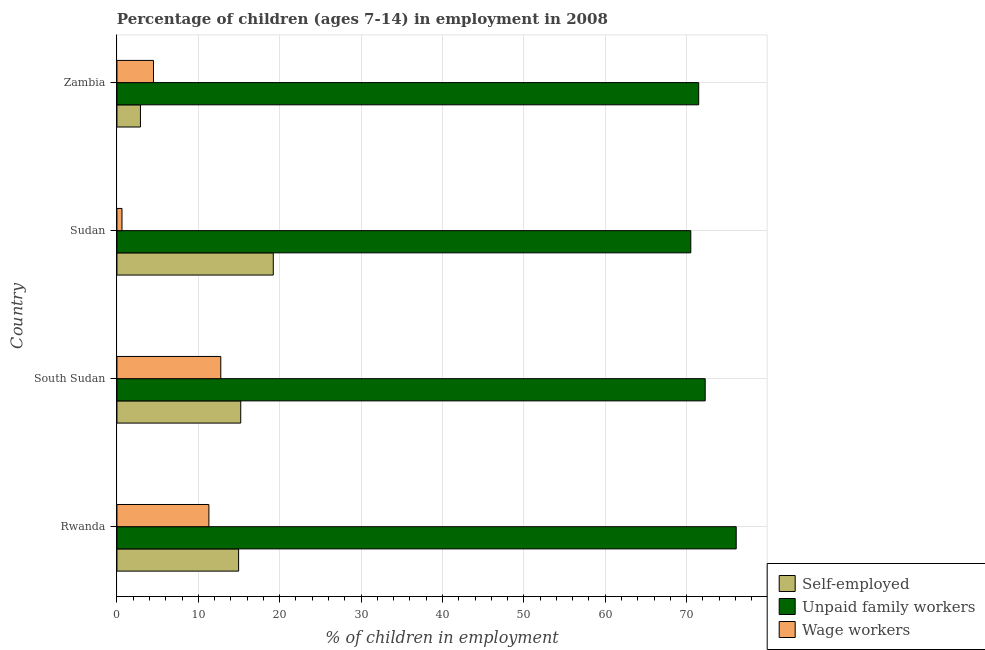Are the number of bars per tick equal to the number of legend labels?
Give a very brief answer. Yes. Are the number of bars on each tick of the Y-axis equal?
Your answer should be very brief. Yes. How many bars are there on the 4th tick from the top?
Ensure brevity in your answer.  3. How many bars are there on the 3rd tick from the bottom?
Your response must be concise. 3. What is the label of the 1st group of bars from the top?
Offer a terse response. Zambia. What is the percentage of self employed children in Zambia?
Make the answer very short. 2.89. Across all countries, what is the maximum percentage of children employed as unpaid family workers?
Your answer should be compact. 76.09. Across all countries, what is the minimum percentage of children employed as unpaid family workers?
Provide a succinct answer. 70.51. In which country was the percentage of children employed as unpaid family workers maximum?
Provide a short and direct response. Rwanda. In which country was the percentage of children employed as unpaid family workers minimum?
Your response must be concise. Sudan. What is the total percentage of self employed children in the graph?
Provide a short and direct response. 52.26. What is the difference between the percentage of children employed as wage workers in Rwanda and that in South Sudan?
Provide a short and direct response. -1.46. What is the difference between the percentage of children employed as wage workers in Rwanda and the percentage of children employed as unpaid family workers in South Sudan?
Ensure brevity in your answer.  -60.98. What is the average percentage of self employed children per country?
Your answer should be compact. 13.06. What is the difference between the percentage of self employed children and percentage of children employed as wage workers in Sudan?
Your answer should be compact. 18.59. What is the ratio of the percentage of children employed as unpaid family workers in Rwanda to that in Sudan?
Ensure brevity in your answer.  1.08. Is the percentage of children employed as wage workers in Rwanda less than that in Sudan?
Provide a short and direct response. No. Is the difference between the percentage of children employed as wage workers in Sudan and Zambia greater than the difference between the percentage of self employed children in Sudan and Zambia?
Provide a succinct answer. No. What is the difference between the highest and the second highest percentage of children employed as wage workers?
Provide a short and direct response. 1.46. What is the difference between the highest and the lowest percentage of children employed as unpaid family workers?
Your answer should be compact. 5.58. Is the sum of the percentage of self employed children in Rwanda and Sudan greater than the maximum percentage of children employed as wage workers across all countries?
Provide a short and direct response. Yes. What does the 1st bar from the top in Zambia represents?
Provide a succinct answer. Wage workers. What does the 3rd bar from the bottom in Rwanda represents?
Give a very brief answer. Wage workers. How many bars are there?
Give a very brief answer. 12. What is the difference between two consecutive major ticks on the X-axis?
Offer a terse response. 10. Are the values on the major ticks of X-axis written in scientific E-notation?
Your response must be concise. No. Does the graph contain any zero values?
Your answer should be compact. No. How many legend labels are there?
Your answer should be very brief. 3. What is the title of the graph?
Offer a very short reply. Percentage of children (ages 7-14) in employment in 2008. Does "Maunufacturing" appear as one of the legend labels in the graph?
Ensure brevity in your answer.  No. What is the label or title of the X-axis?
Provide a short and direct response. % of children in employment. What is the label or title of the Y-axis?
Provide a short and direct response. Country. What is the % of children in employment of Self-employed in Rwanda?
Provide a short and direct response. 14.95. What is the % of children in employment in Unpaid family workers in Rwanda?
Offer a very short reply. 76.09. What is the % of children in employment of Wage workers in Rwanda?
Give a very brief answer. 11.3. What is the % of children in employment in Self-employed in South Sudan?
Provide a short and direct response. 15.21. What is the % of children in employment in Unpaid family workers in South Sudan?
Your answer should be very brief. 72.28. What is the % of children in employment in Wage workers in South Sudan?
Your answer should be very brief. 12.76. What is the % of children in employment in Self-employed in Sudan?
Ensure brevity in your answer.  19.21. What is the % of children in employment of Unpaid family workers in Sudan?
Your response must be concise. 70.51. What is the % of children in employment of Wage workers in Sudan?
Offer a very short reply. 0.62. What is the % of children in employment of Self-employed in Zambia?
Make the answer very short. 2.89. What is the % of children in employment in Unpaid family workers in Zambia?
Offer a terse response. 71.48. What is the % of children in employment in Wage workers in Zambia?
Your answer should be very brief. 4.49. Across all countries, what is the maximum % of children in employment of Self-employed?
Ensure brevity in your answer.  19.21. Across all countries, what is the maximum % of children in employment of Unpaid family workers?
Provide a short and direct response. 76.09. Across all countries, what is the maximum % of children in employment in Wage workers?
Ensure brevity in your answer.  12.76. Across all countries, what is the minimum % of children in employment of Self-employed?
Provide a short and direct response. 2.89. Across all countries, what is the minimum % of children in employment of Unpaid family workers?
Offer a terse response. 70.51. Across all countries, what is the minimum % of children in employment in Wage workers?
Ensure brevity in your answer.  0.62. What is the total % of children in employment of Self-employed in the graph?
Give a very brief answer. 52.26. What is the total % of children in employment in Unpaid family workers in the graph?
Provide a short and direct response. 290.36. What is the total % of children in employment in Wage workers in the graph?
Your answer should be very brief. 29.17. What is the difference between the % of children in employment of Self-employed in Rwanda and that in South Sudan?
Offer a very short reply. -0.26. What is the difference between the % of children in employment of Unpaid family workers in Rwanda and that in South Sudan?
Provide a short and direct response. 3.81. What is the difference between the % of children in employment of Wage workers in Rwanda and that in South Sudan?
Provide a short and direct response. -1.46. What is the difference between the % of children in employment of Self-employed in Rwanda and that in Sudan?
Offer a terse response. -4.26. What is the difference between the % of children in employment of Unpaid family workers in Rwanda and that in Sudan?
Provide a short and direct response. 5.58. What is the difference between the % of children in employment in Wage workers in Rwanda and that in Sudan?
Ensure brevity in your answer.  10.68. What is the difference between the % of children in employment of Self-employed in Rwanda and that in Zambia?
Your answer should be compact. 12.06. What is the difference between the % of children in employment of Unpaid family workers in Rwanda and that in Zambia?
Offer a very short reply. 4.61. What is the difference between the % of children in employment of Wage workers in Rwanda and that in Zambia?
Your answer should be compact. 6.81. What is the difference between the % of children in employment of Self-employed in South Sudan and that in Sudan?
Your answer should be very brief. -4. What is the difference between the % of children in employment of Unpaid family workers in South Sudan and that in Sudan?
Offer a very short reply. 1.77. What is the difference between the % of children in employment of Wage workers in South Sudan and that in Sudan?
Provide a short and direct response. 12.14. What is the difference between the % of children in employment in Self-employed in South Sudan and that in Zambia?
Provide a succinct answer. 12.32. What is the difference between the % of children in employment of Unpaid family workers in South Sudan and that in Zambia?
Offer a terse response. 0.8. What is the difference between the % of children in employment of Wage workers in South Sudan and that in Zambia?
Offer a terse response. 8.27. What is the difference between the % of children in employment of Self-employed in Sudan and that in Zambia?
Ensure brevity in your answer.  16.32. What is the difference between the % of children in employment of Unpaid family workers in Sudan and that in Zambia?
Offer a terse response. -0.97. What is the difference between the % of children in employment in Wage workers in Sudan and that in Zambia?
Ensure brevity in your answer.  -3.87. What is the difference between the % of children in employment of Self-employed in Rwanda and the % of children in employment of Unpaid family workers in South Sudan?
Make the answer very short. -57.33. What is the difference between the % of children in employment of Self-employed in Rwanda and the % of children in employment of Wage workers in South Sudan?
Ensure brevity in your answer.  2.19. What is the difference between the % of children in employment in Unpaid family workers in Rwanda and the % of children in employment in Wage workers in South Sudan?
Your answer should be compact. 63.33. What is the difference between the % of children in employment in Self-employed in Rwanda and the % of children in employment in Unpaid family workers in Sudan?
Your answer should be very brief. -55.56. What is the difference between the % of children in employment of Self-employed in Rwanda and the % of children in employment of Wage workers in Sudan?
Provide a succinct answer. 14.33. What is the difference between the % of children in employment of Unpaid family workers in Rwanda and the % of children in employment of Wage workers in Sudan?
Offer a very short reply. 75.47. What is the difference between the % of children in employment of Self-employed in Rwanda and the % of children in employment of Unpaid family workers in Zambia?
Offer a terse response. -56.53. What is the difference between the % of children in employment in Self-employed in Rwanda and the % of children in employment in Wage workers in Zambia?
Your answer should be very brief. 10.46. What is the difference between the % of children in employment in Unpaid family workers in Rwanda and the % of children in employment in Wage workers in Zambia?
Your answer should be compact. 71.6. What is the difference between the % of children in employment of Self-employed in South Sudan and the % of children in employment of Unpaid family workers in Sudan?
Make the answer very short. -55.3. What is the difference between the % of children in employment in Self-employed in South Sudan and the % of children in employment in Wage workers in Sudan?
Make the answer very short. 14.59. What is the difference between the % of children in employment of Unpaid family workers in South Sudan and the % of children in employment of Wage workers in Sudan?
Provide a short and direct response. 71.66. What is the difference between the % of children in employment of Self-employed in South Sudan and the % of children in employment of Unpaid family workers in Zambia?
Provide a short and direct response. -56.27. What is the difference between the % of children in employment in Self-employed in South Sudan and the % of children in employment in Wage workers in Zambia?
Ensure brevity in your answer.  10.72. What is the difference between the % of children in employment of Unpaid family workers in South Sudan and the % of children in employment of Wage workers in Zambia?
Your response must be concise. 67.79. What is the difference between the % of children in employment in Self-employed in Sudan and the % of children in employment in Unpaid family workers in Zambia?
Offer a very short reply. -52.27. What is the difference between the % of children in employment in Self-employed in Sudan and the % of children in employment in Wage workers in Zambia?
Provide a succinct answer. 14.72. What is the difference between the % of children in employment of Unpaid family workers in Sudan and the % of children in employment of Wage workers in Zambia?
Provide a succinct answer. 66.02. What is the average % of children in employment of Self-employed per country?
Provide a short and direct response. 13.06. What is the average % of children in employment of Unpaid family workers per country?
Your answer should be very brief. 72.59. What is the average % of children in employment in Wage workers per country?
Make the answer very short. 7.29. What is the difference between the % of children in employment in Self-employed and % of children in employment in Unpaid family workers in Rwanda?
Provide a succinct answer. -61.14. What is the difference between the % of children in employment in Self-employed and % of children in employment in Wage workers in Rwanda?
Your answer should be very brief. 3.65. What is the difference between the % of children in employment of Unpaid family workers and % of children in employment of Wage workers in Rwanda?
Offer a very short reply. 64.79. What is the difference between the % of children in employment of Self-employed and % of children in employment of Unpaid family workers in South Sudan?
Keep it short and to the point. -57.07. What is the difference between the % of children in employment of Self-employed and % of children in employment of Wage workers in South Sudan?
Your answer should be very brief. 2.45. What is the difference between the % of children in employment of Unpaid family workers and % of children in employment of Wage workers in South Sudan?
Make the answer very short. 59.52. What is the difference between the % of children in employment of Self-employed and % of children in employment of Unpaid family workers in Sudan?
Your answer should be very brief. -51.3. What is the difference between the % of children in employment of Self-employed and % of children in employment of Wage workers in Sudan?
Your answer should be compact. 18.59. What is the difference between the % of children in employment in Unpaid family workers and % of children in employment in Wage workers in Sudan?
Give a very brief answer. 69.89. What is the difference between the % of children in employment of Self-employed and % of children in employment of Unpaid family workers in Zambia?
Ensure brevity in your answer.  -68.59. What is the difference between the % of children in employment in Unpaid family workers and % of children in employment in Wage workers in Zambia?
Your response must be concise. 66.99. What is the ratio of the % of children in employment of Self-employed in Rwanda to that in South Sudan?
Keep it short and to the point. 0.98. What is the ratio of the % of children in employment in Unpaid family workers in Rwanda to that in South Sudan?
Offer a very short reply. 1.05. What is the ratio of the % of children in employment of Wage workers in Rwanda to that in South Sudan?
Ensure brevity in your answer.  0.89. What is the ratio of the % of children in employment of Self-employed in Rwanda to that in Sudan?
Ensure brevity in your answer.  0.78. What is the ratio of the % of children in employment in Unpaid family workers in Rwanda to that in Sudan?
Keep it short and to the point. 1.08. What is the ratio of the % of children in employment in Wage workers in Rwanda to that in Sudan?
Offer a very short reply. 18.23. What is the ratio of the % of children in employment of Self-employed in Rwanda to that in Zambia?
Provide a succinct answer. 5.17. What is the ratio of the % of children in employment of Unpaid family workers in Rwanda to that in Zambia?
Provide a short and direct response. 1.06. What is the ratio of the % of children in employment of Wage workers in Rwanda to that in Zambia?
Ensure brevity in your answer.  2.52. What is the ratio of the % of children in employment in Self-employed in South Sudan to that in Sudan?
Make the answer very short. 0.79. What is the ratio of the % of children in employment in Unpaid family workers in South Sudan to that in Sudan?
Offer a terse response. 1.03. What is the ratio of the % of children in employment of Wage workers in South Sudan to that in Sudan?
Ensure brevity in your answer.  20.58. What is the ratio of the % of children in employment in Self-employed in South Sudan to that in Zambia?
Make the answer very short. 5.26. What is the ratio of the % of children in employment of Unpaid family workers in South Sudan to that in Zambia?
Your answer should be very brief. 1.01. What is the ratio of the % of children in employment in Wage workers in South Sudan to that in Zambia?
Your answer should be compact. 2.84. What is the ratio of the % of children in employment of Self-employed in Sudan to that in Zambia?
Your answer should be compact. 6.65. What is the ratio of the % of children in employment of Unpaid family workers in Sudan to that in Zambia?
Provide a succinct answer. 0.99. What is the ratio of the % of children in employment of Wage workers in Sudan to that in Zambia?
Keep it short and to the point. 0.14. What is the difference between the highest and the second highest % of children in employment of Self-employed?
Provide a succinct answer. 4. What is the difference between the highest and the second highest % of children in employment of Unpaid family workers?
Your answer should be compact. 3.81. What is the difference between the highest and the second highest % of children in employment of Wage workers?
Your answer should be very brief. 1.46. What is the difference between the highest and the lowest % of children in employment of Self-employed?
Keep it short and to the point. 16.32. What is the difference between the highest and the lowest % of children in employment in Unpaid family workers?
Your answer should be compact. 5.58. What is the difference between the highest and the lowest % of children in employment of Wage workers?
Provide a short and direct response. 12.14. 